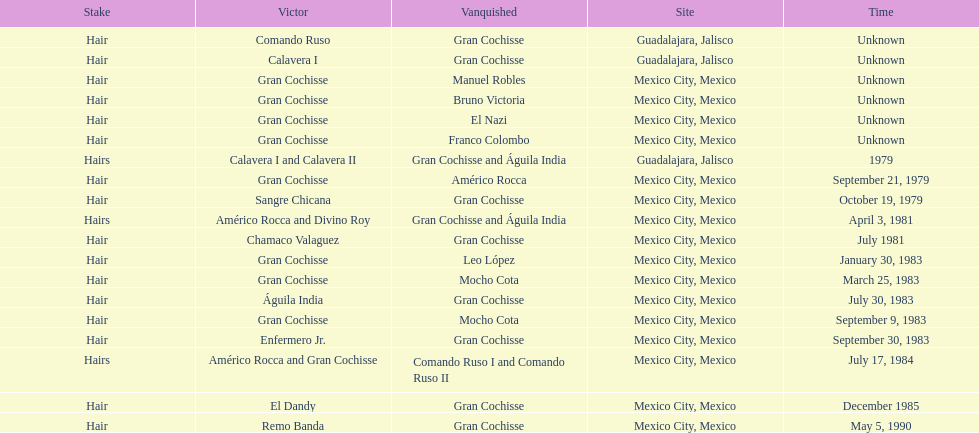When did bruno victoria lose his first game? Unknown. 